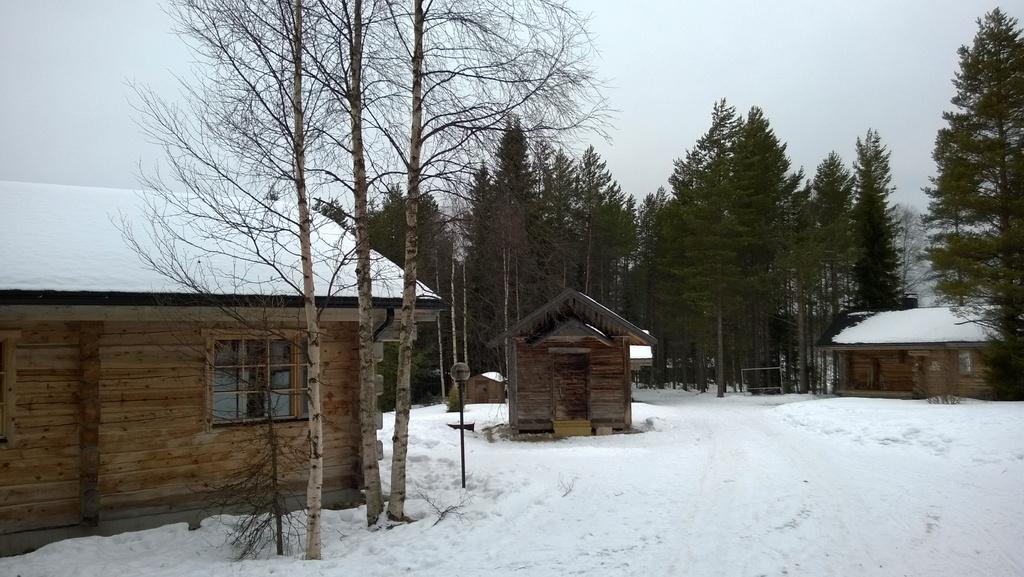Could you give a brief overview of what you see in this image? In this picture I can see there are some buildings and there are trees and snow on the floor and the sky is clear. 